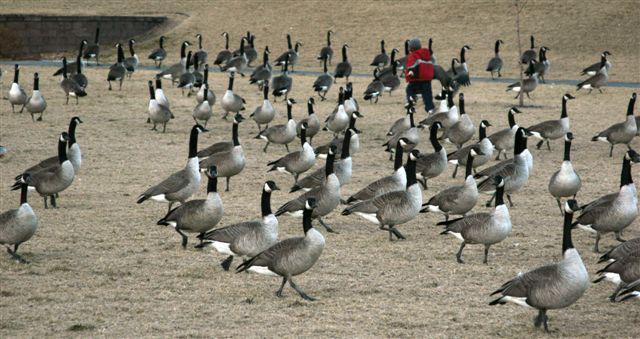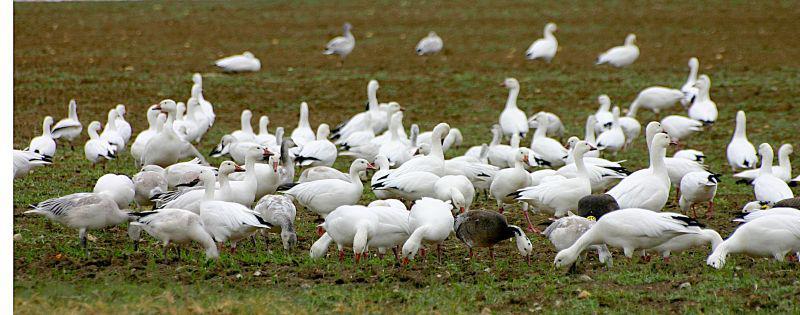The first image is the image on the left, the second image is the image on the right. Examine the images to the left and right. Is the description "There are geese visible on the water" accurate? Answer yes or no. No. 